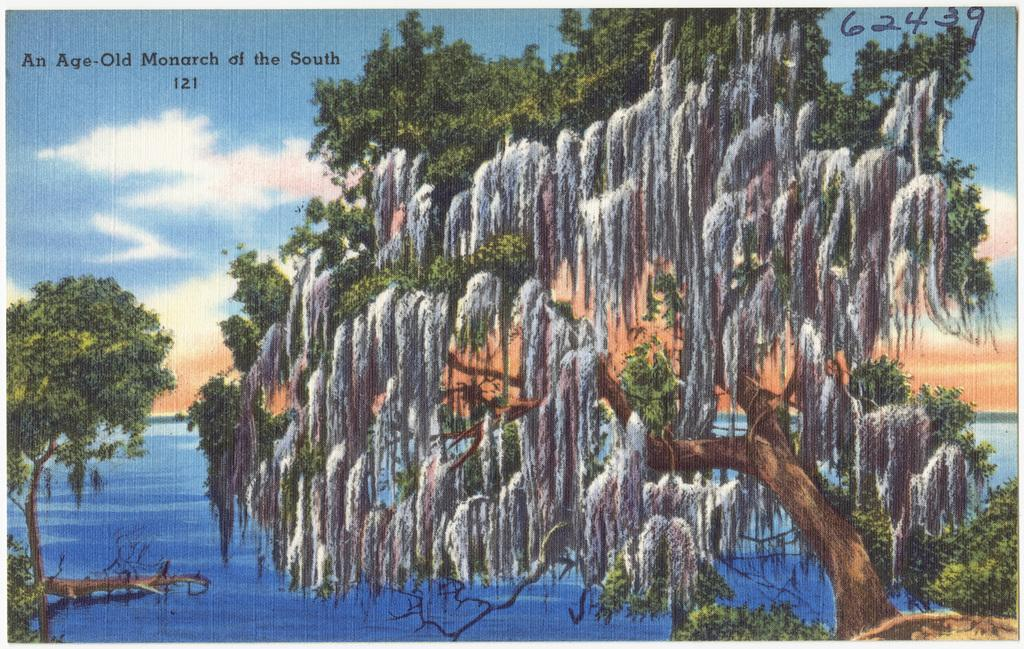What is the main subject of the image? The main subject of the image is a photo. What elements are present in the photo? The photo contains trees, water, and sky. What is located at the top of the image? There is text and numbers at the top of the image. What type of force can be seen acting on the trees in the image? There is no force acting on the trees in the image; it is a still photo. Can you hear any sounds coming from the ear in the image? There is no ear present in the image, so it is not possible to hear any sounds. 